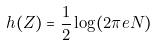<formula> <loc_0><loc_0><loc_500><loc_500>h ( Z ) = { \frac { 1 } { 2 } } \log ( 2 \pi e N ) \,</formula> 